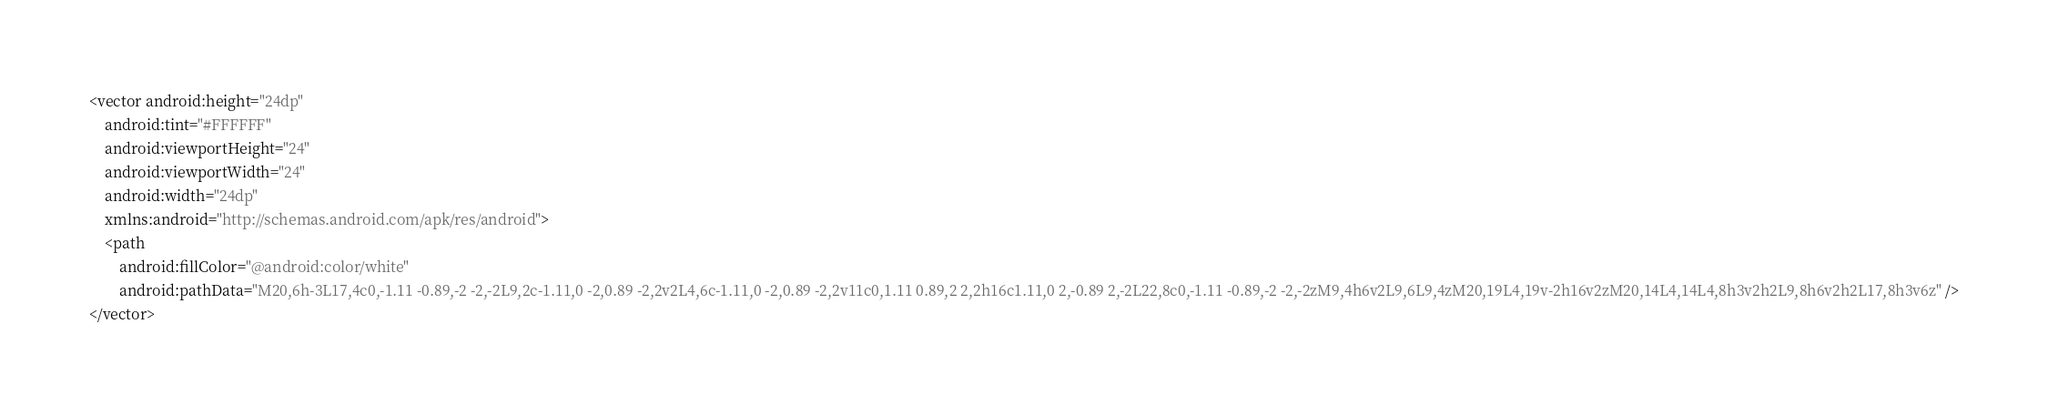Convert code to text. <code><loc_0><loc_0><loc_500><loc_500><_XML_><vector android:height="24dp"
    android:tint="#FFFFFF"
    android:viewportHeight="24"
    android:viewportWidth="24"
    android:width="24dp"
    xmlns:android="http://schemas.android.com/apk/res/android">
    <path
        android:fillColor="@android:color/white"
        android:pathData="M20,6h-3L17,4c0,-1.11 -0.89,-2 -2,-2L9,2c-1.11,0 -2,0.89 -2,2v2L4,6c-1.11,0 -2,0.89 -2,2v11c0,1.11 0.89,2 2,2h16c1.11,0 2,-0.89 2,-2L22,8c0,-1.11 -0.89,-2 -2,-2zM9,4h6v2L9,6L9,4zM20,19L4,19v-2h16v2zM20,14L4,14L4,8h3v2h2L9,8h6v2h2L17,8h3v6z" />
</vector>
</code> 